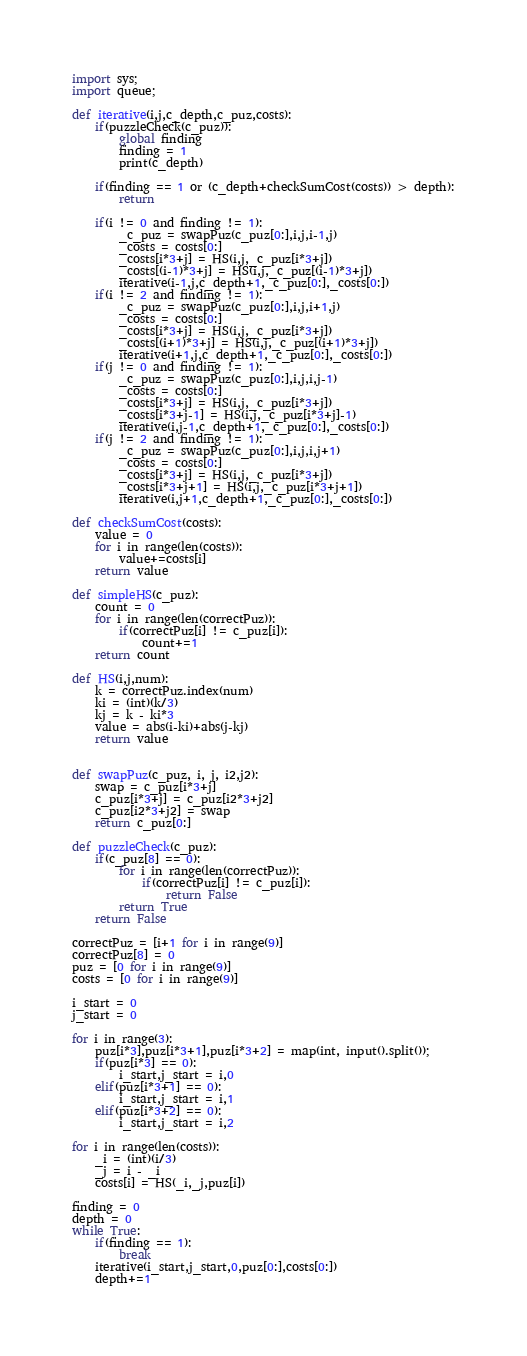Convert code to text. <code><loc_0><loc_0><loc_500><loc_500><_Python_>import sys;
import queue;

def iterative(i,j,c_depth,c_puz,costs):
    if(puzzleCheck(c_puz)):
        global finding
        finding = 1
        print(c_depth)

    if(finding == 1 or (c_depth+checkSumCost(costs)) > depth):
        return

    if(i != 0 and finding != 1):
        _c_puz = swapPuz(c_puz[0:],i,j,i-1,j)
        _costs = costs[0:]
        _costs[i*3+j] = HS(i,j,_c_puz[i*3+j])
        _costs[(i-1)*3+j] = HS(i,j,_c_puz[(i-1)*3+j])
        iterative(i-1,j,c_depth+1,_c_puz[0:],_costs[0:])
    if(i != 2 and finding != 1):
        _c_puz = swapPuz(c_puz[0:],i,j,i+1,j)
        _costs = costs[0:]
        _costs[i*3+j] = HS(i,j,_c_puz[i*3+j])
        _costs[(i+1)*3+j] = HS(i,j,_c_puz[(i+1)*3+j])
        iterative(i+1,j,c_depth+1,_c_puz[0:],_costs[0:])
    if(j != 0 and finding != 1):
        _c_puz = swapPuz(c_puz[0:],i,j,i,j-1)
        _costs = costs[0:]
        _costs[i*3+j] = HS(i,j,_c_puz[i*3+j])
        _costs[i*3+j-1] = HS(i,j,_c_puz[i*3+j]-1)
        iterative(i,j-1,c_depth+1,_c_puz[0:],_costs[0:])
    if(j != 2 and finding != 1):
        _c_puz = swapPuz(c_puz[0:],i,j,i,j+1)
        _costs = costs[0:]
        _costs[i*3+j] = HS(i,j,_c_puz[i*3+j])
        _costs[i*3+j+1] = HS(i,j,_c_puz[i*3+j+1])
        iterative(i,j+1,c_depth+1,_c_puz[0:],_costs[0:])

def checkSumCost(costs):
    value = 0
    for i in range(len(costs)):
        value+=costs[i]
    return value

def simpleHS(c_puz):
    count = 0
    for i in range(len(correctPuz)):
        if(correctPuz[i] != c_puz[i]):
            count+=1
    return count

def HS(i,j,num):
    k = correctPuz.index(num)
    ki = (int)(k/3)
    kj = k - ki*3
    value = abs(i-ki)+abs(j-kj) 
    return value


def swapPuz(c_puz, i, j, i2,j2):
    swap = c_puz[i*3+j]
    c_puz[i*3+j] = c_puz[i2*3+j2]
    c_puz[i2*3+j2] = swap
    return c_puz[0:]

def puzzleCheck(c_puz):
    if(c_puz[8] == 0):
        for i in range(len(correctPuz)):
            if(correctPuz[i] != c_puz[i]):
                return False
        return True
    return False

correctPuz = [i+1 for i in range(9)]
correctPuz[8] = 0
puz = [0 for i in range(9)]
costs = [0 for i in range(9)]

i_start = 0
j_start = 0

for i in range(3):
    puz[i*3],puz[i*3+1],puz[i*3+2] = map(int, input().split());
    if(puz[i*3] == 0):
        i_start,j_start = i,0
    elif(puz[i*3+1] == 0):
        i_start,j_start = i,1
    elif(puz[i*3+2] == 0):
        i_start,j_start = i,2

for i in range(len(costs)):
    _i = (int)(i/3)
    _j = i - _i
    costs[i] = HS(_i,_j,puz[i])

finding = 0
depth = 0
while True:
    if(finding == 1):
        break
    iterative(i_start,j_start,0,puz[0:],costs[0:])
    depth+=1



</code> 